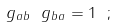Convert formula to latex. <formula><loc_0><loc_0><loc_500><loc_500>g _ { a b } \ g _ { b a } = 1 \ ;</formula> 